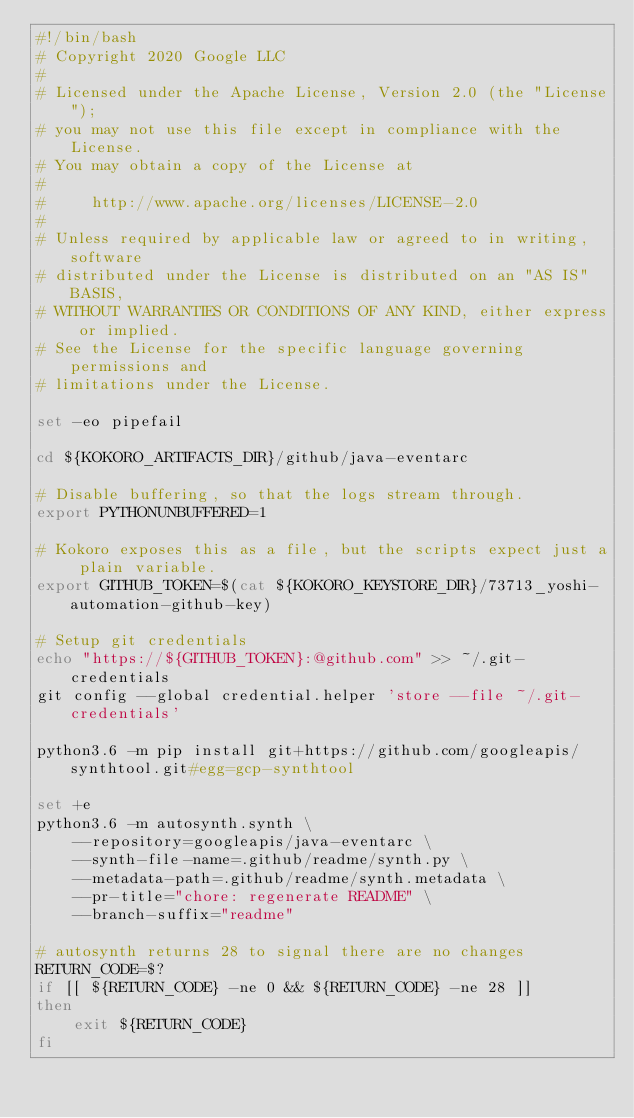<code> <loc_0><loc_0><loc_500><loc_500><_Bash_>#!/bin/bash
# Copyright 2020 Google LLC
#
# Licensed under the Apache License, Version 2.0 (the "License");
# you may not use this file except in compliance with the License.
# You may obtain a copy of the License at
#
#     http://www.apache.org/licenses/LICENSE-2.0
#
# Unless required by applicable law or agreed to in writing, software
# distributed under the License is distributed on an "AS IS" BASIS,
# WITHOUT WARRANTIES OR CONDITIONS OF ANY KIND, either express or implied.
# See the License for the specific language governing permissions and
# limitations under the License.

set -eo pipefail

cd ${KOKORO_ARTIFACTS_DIR}/github/java-eventarc

# Disable buffering, so that the logs stream through.
export PYTHONUNBUFFERED=1

# Kokoro exposes this as a file, but the scripts expect just a plain variable.
export GITHUB_TOKEN=$(cat ${KOKORO_KEYSTORE_DIR}/73713_yoshi-automation-github-key)

# Setup git credentials
echo "https://${GITHUB_TOKEN}:@github.com" >> ~/.git-credentials
git config --global credential.helper 'store --file ~/.git-credentials'

python3.6 -m pip install git+https://github.com/googleapis/synthtool.git#egg=gcp-synthtool

set +e
python3.6 -m autosynth.synth \
    --repository=googleapis/java-eventarc \
    --synth-file-name=.github/readme/synth.py \
    --metadata-path=.github/readme/synth.metadata \
    --pr-title="chore: regenerate README" \
    --branch-suffix="readme"

# autosynth returns 28 to signal there are no changes
RETURN_CODE=$?
if [[ ${RETURN_CODE} -ne 0 && ${RETURN_CODE} -ne 28 ]]
then
    exit ${RETURN_CODE}
fi
</code> 